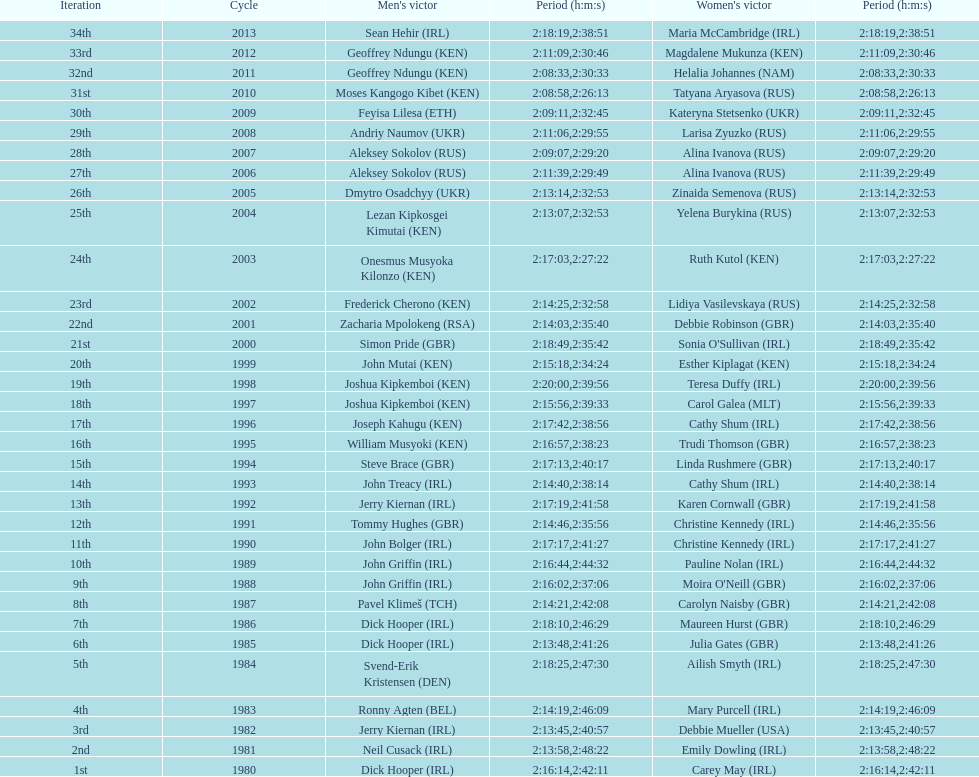Who won after joseph kipkemboi's winning streak ended? John Mutai (KEN). 